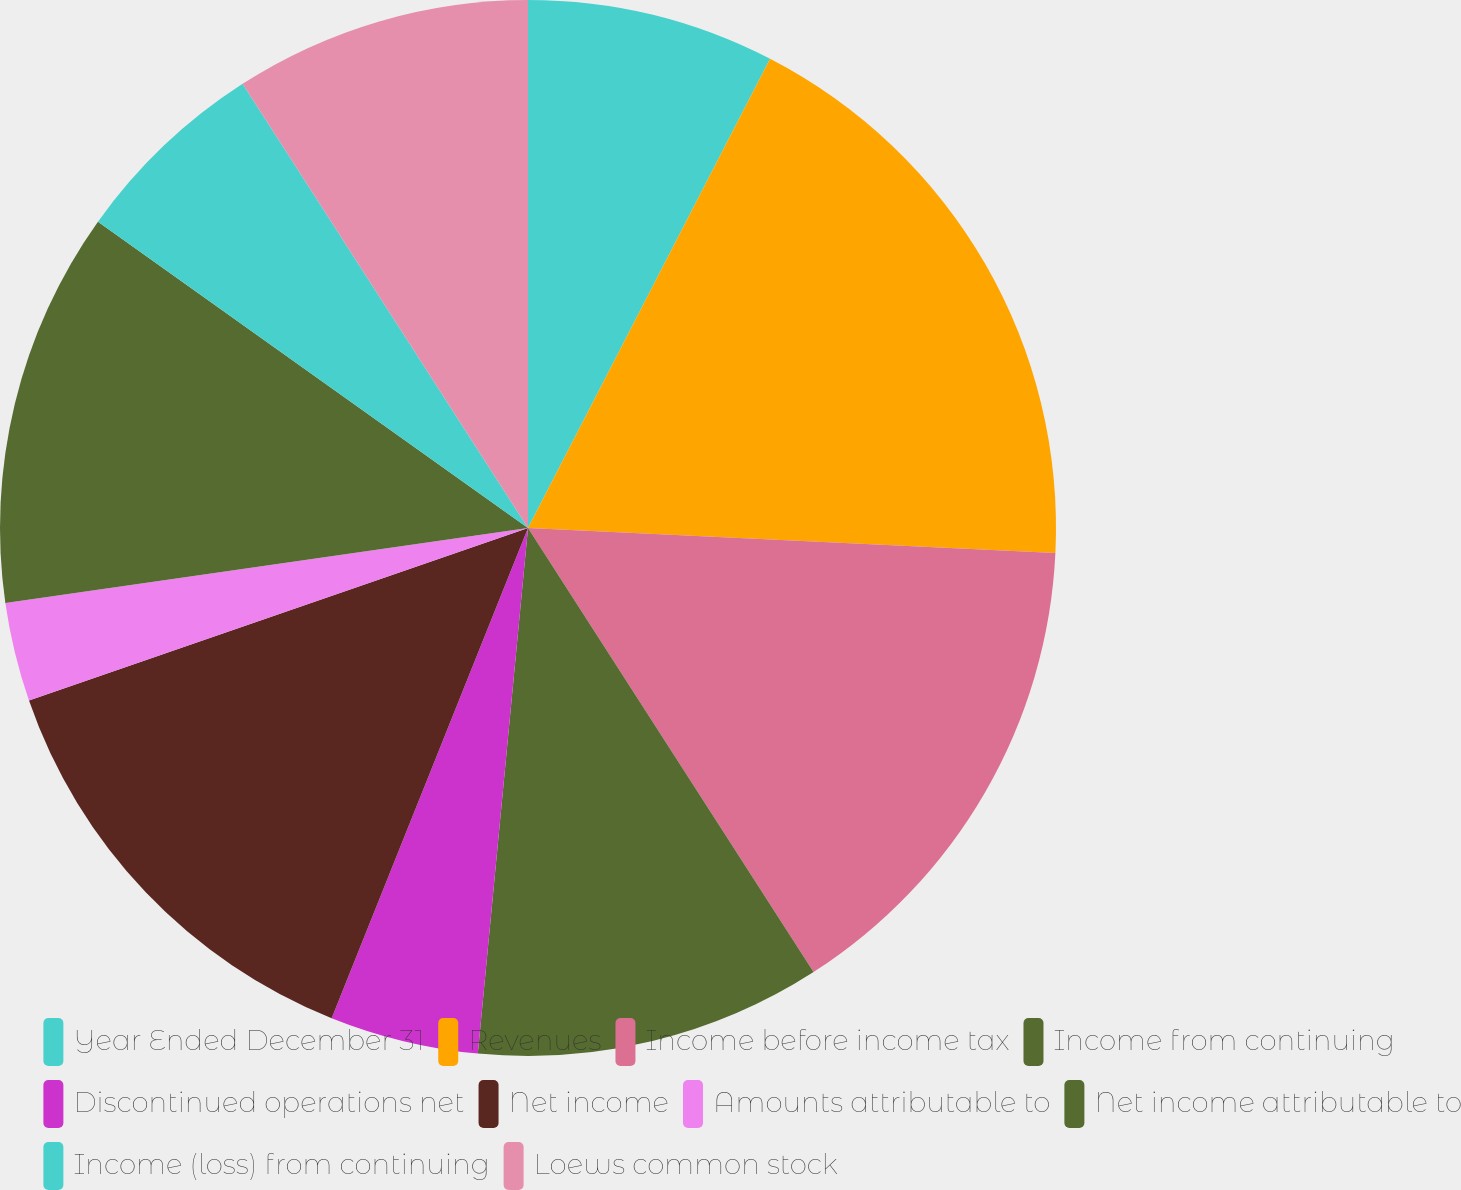Convert chart. <chart><loc_0><loc_0><loc_500><loc_500><pie_chart><fcel>Year Ended December 31<fcel>Revenues<fcel>Income before income tax<fcel>Income from continuing<fcel>Discontinued operations net<fcel>Net income<fcel>Amounts attributable to<fcel>Net income attributable to<fcel>Income (loss) from continuing<fcel>Loews common stock<nl><fcel>7.58%<fcel>18.18%<fcel>15.15%<fcel>10.61%<fcel>4.55%<fcel>13.64%<fcel>3.03%<fcel>12.12%<fcel>6.06%<fcel>9.09%<nl></chart> 